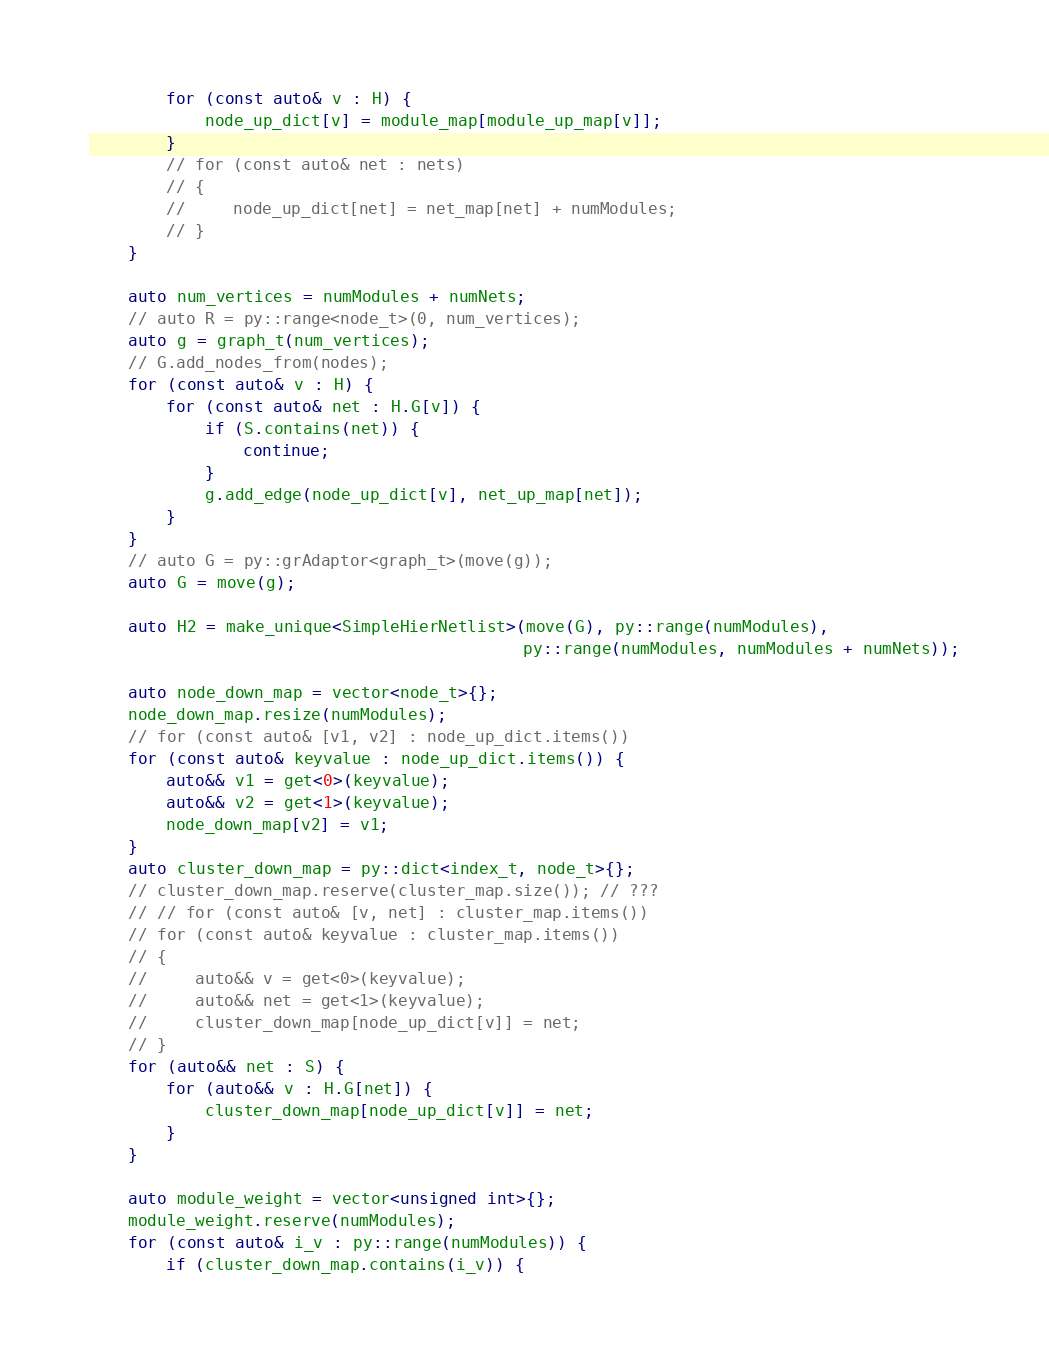<code> <loc_0><loc_0><loc_500><loc_500><_C++_>
        for (const auto& v : H) {
            node_up_dict[v] = module_map[module_up_map[v]];
        }
        // for (const auto& net : nets)
        // {
        //     node_up_dict[net] = net_map[net] + numModules;
        // }
    }

    auto num_vertices = numModules + numNets;
    // auto R = py::range<node_t>(0, num_vertices);
    auto g = graph_t(num_vertices);
    // G.add_nodes_from(nodes);
    for (const auto& v : H) {
        for (const auto& net : H.G[v]) {
            if (S.contains(net)) {
                continue;
            }
            g.add_edge(node_up_dict[v], net_up_map[net]);
        }
    }
    // auto G = py::grAdaptor<graph_t>(move(g));
    auto G = move(g);

    auto H2 = make_unique<SimpleHierNetlist>(move(G), py::range(numModules),
                                             py::range(numModules, numModules + numNets));

    auto node_down_map = vector<node_t>{};
    node_down_map.resize(numModules);
    // for (const auto& [v1, v2] : node_up_dict.items())
    for (const auto& keyvalue : node_up_dict.items()) {
        auto&& v1 = get<0>(keyvalue);
        auto&& v2 = get<1>(keyvalue);
        node_down_map[v2] = v1;
    }
    auto cluster_down_map = py::dict<index_t, node_t>{};
    // cluster_down_map.reserve(cluster_map.size()); // ???
    // // for (const auto& [v, net] : cluster_map.items())
    // for (const auto& keyvalue : cluster_map.items())
    // {
    //     auto&& v = get<0>(keyvalue);
    //     auto&& net = get<1>(keyvalue);
    //     cluster_down_map[node_up_dict[v]] = net;
    // }
    for (auto&& net : S) {
        for (auto&& v : H.G[net]) {
            cluster_down_map[node_up_dict[v]] = net;
        }
    }

    auto module_weight = vector<unsigned int>{};
    module_weight.reserve(numModules);
    for (const auto& i_v : py::range(numModules)) {
        if (cluster_down_map.contains(i_v)) {</code> 